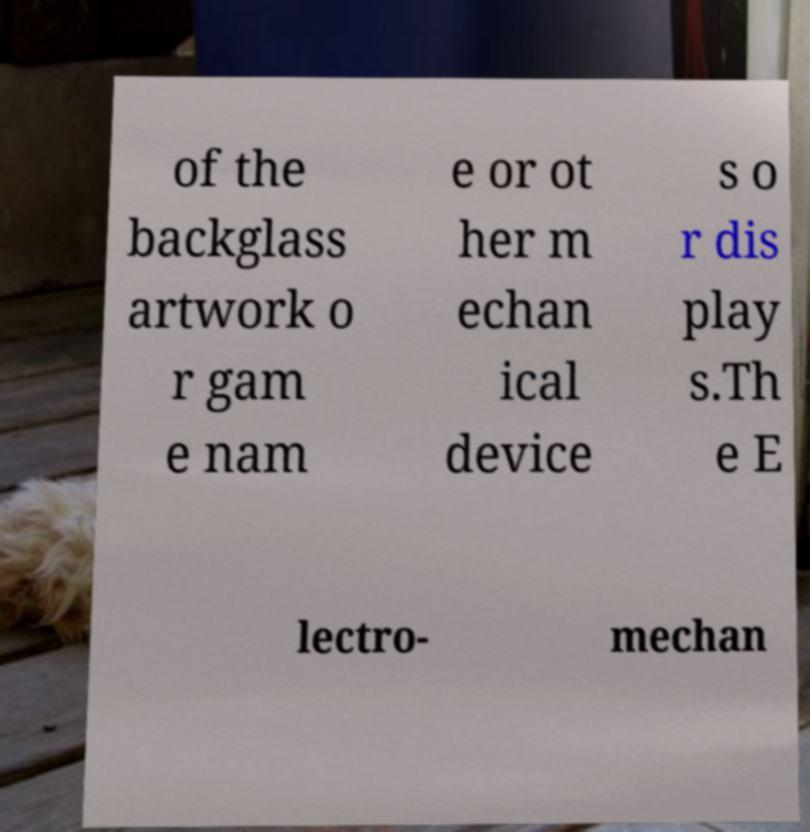Could you assist in decoding the text presented in this image and type it out clearly? of the backglass artwork o r gam e nam e or ot her m echan ical device s o r dis play s.Th e E lectro- mechan 